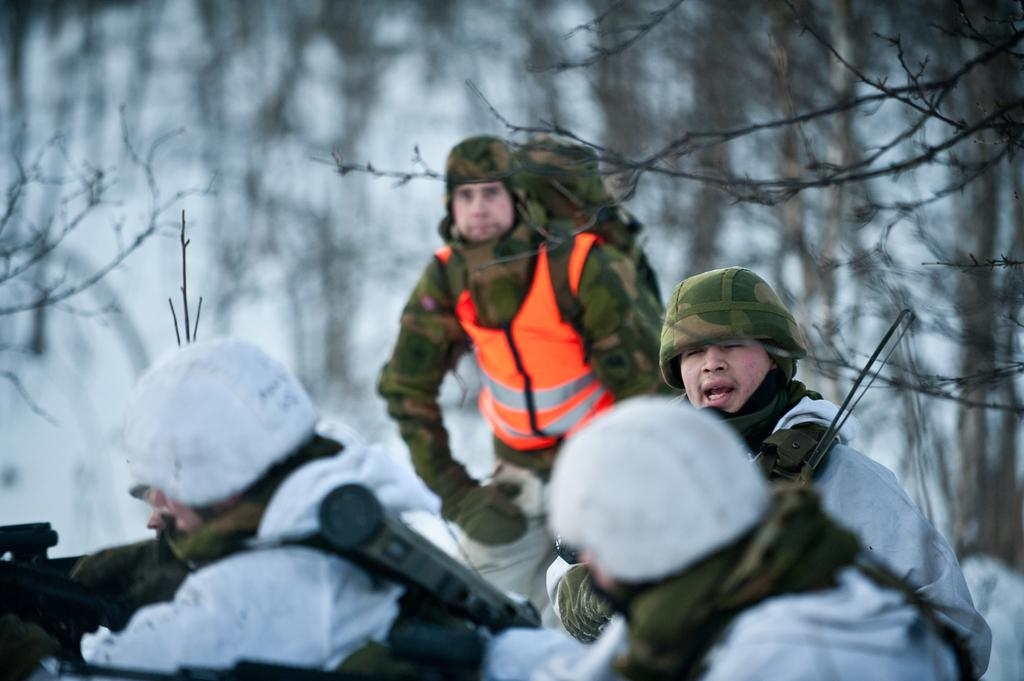How many people are in the image? There are four persons in the image. What can be seen in the background of the image? There are trees and snow visible in the background of the image. What type of cherry is being served on the table in the image? There is no table or cherry present in the image. 